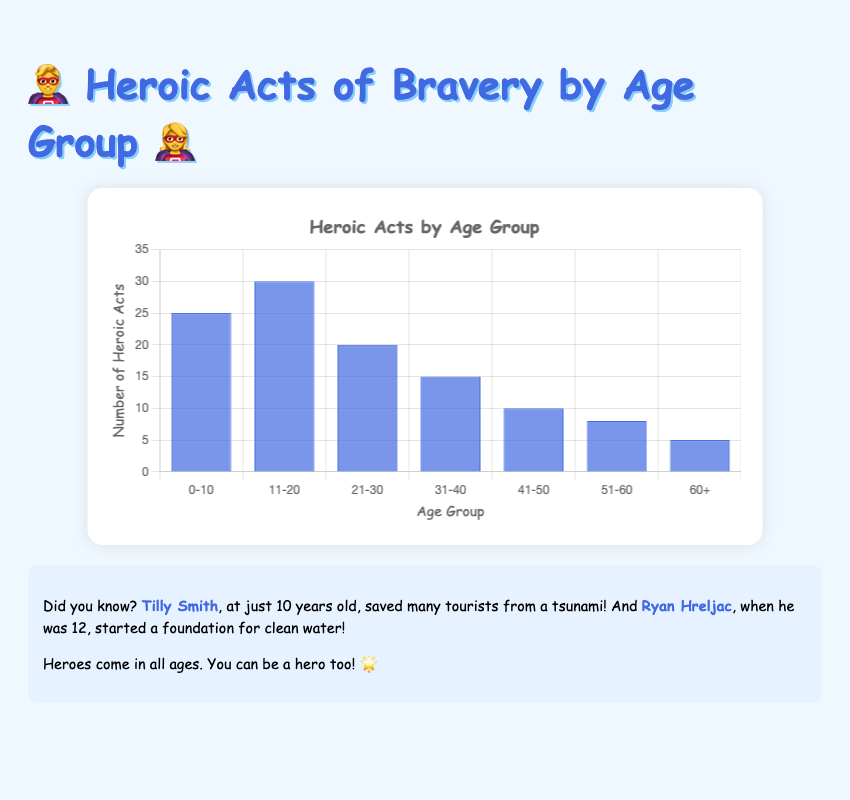Which age group has the highest number of heroic acts? From the bar chart, the bar representing the 11-20 age group is the tallest, indicating it has the highest number of heroic acts.
Answer: 11-20 Which age group performed more heroic acts: 21-30 or 31-40? By comparing the heights of the bars, the bar for the 21-30 age group is higher than the bar for the 31-40 age group, meaning they performed more heroic acts.
Answer: 21-30 What is the total number of heroic acts performed by individuals aged 41-50 and 51-60? The number of acts for 41-50 is 10 and for 51-60 is 8. Adding them gives 10 + 8 = 18.
Answer: 18 Which age group has the lowest number of heroic acts? The shortest bar in the chart represents the 60+ age group, indicating it has the lowest number of heroic acts.
Answer: 60+ How many more heroic acts did the 11-20 age group perform compared to the 31-40 age group? The 11-20 age group performed 30 acts, and the 31-40 age group performed 15 acts. The difference is 30 - 15 = 15.
Answer: 15 What is the average number of heroic acts performed by the age groups 0-10, 21-30, and 41-50? The number of acts for 0-10 is 25, for 21-30 is 20, and for 41-50 is 10. The sum is 25 + 20 + 10 = 55. The average is 55 / 3 ≈ 18.33.
Answer: 18.33 Which age groups performed an equal number of heroic acts? The bars for the 51-60 (8 acts) and 60+ (5 acts) age groups are different heights, so no age groups performed an equal number of acts.
Answer: None What is the difference in the number of acts between the age groups 0-10 and 60+? The number of acts for 0-10 is 25 and for 60+ is 5. The difference is 25 - 5 = 20.
Answer: 20 How many heroic acts were performed in total by all the age groups combined? The total number is 25 (0-10) + 30 (11-20) + 20 (21-30) + 15 (31-40) + 10 (41-50) + 8 (51-60) + 5 (60+). Summing these gives 113.
Answer: 113 